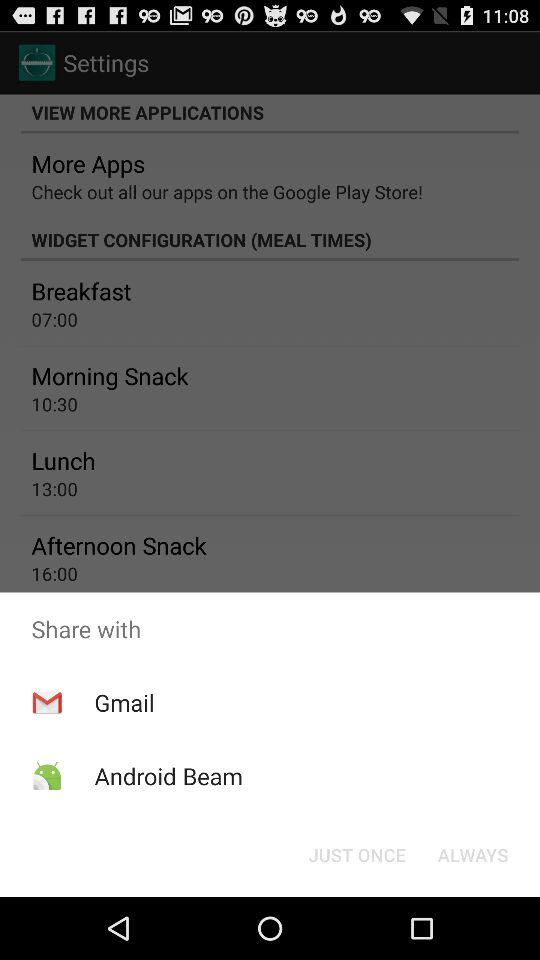What are the different mediums to share? The different mediums are "Gmail" and "Android Beam". 